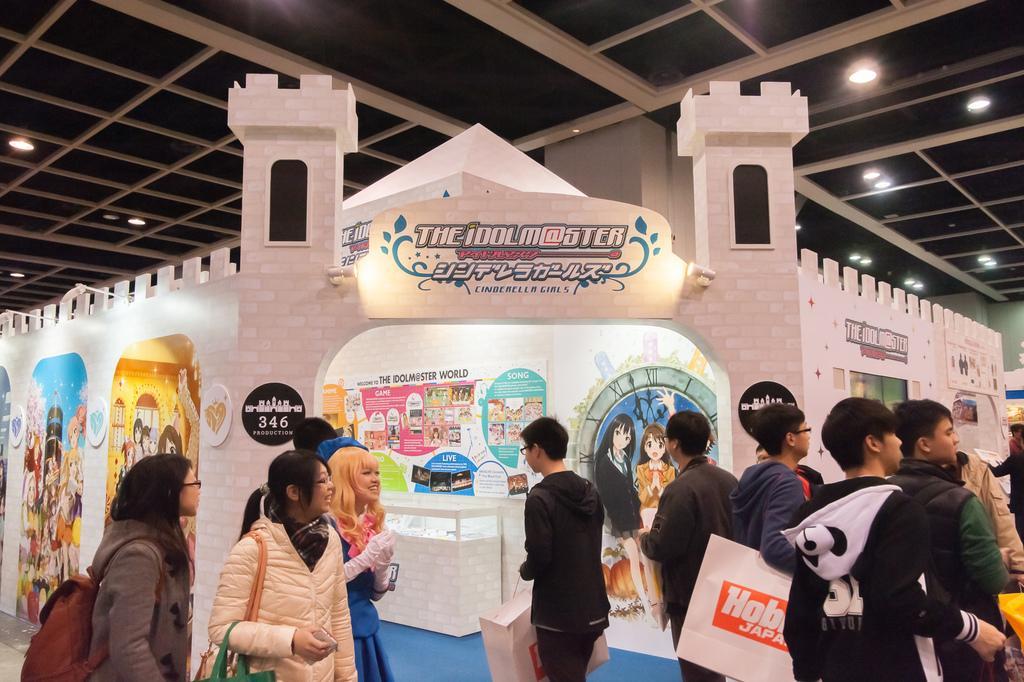Could you give a brief overview of what you see in this image? In this picture there are group of people. At the back there is a building and there are boards and there are pictures of group of people and there is text on the building and there is a table. At the top there are lights. At the bottom there is a floor. 